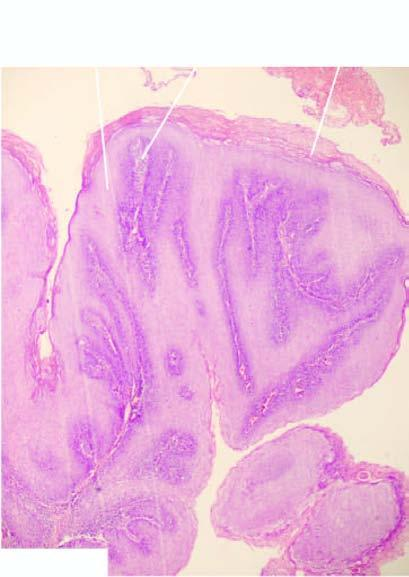s there any papillomatosis?
Answer the question using a single word or phrase. Yes 